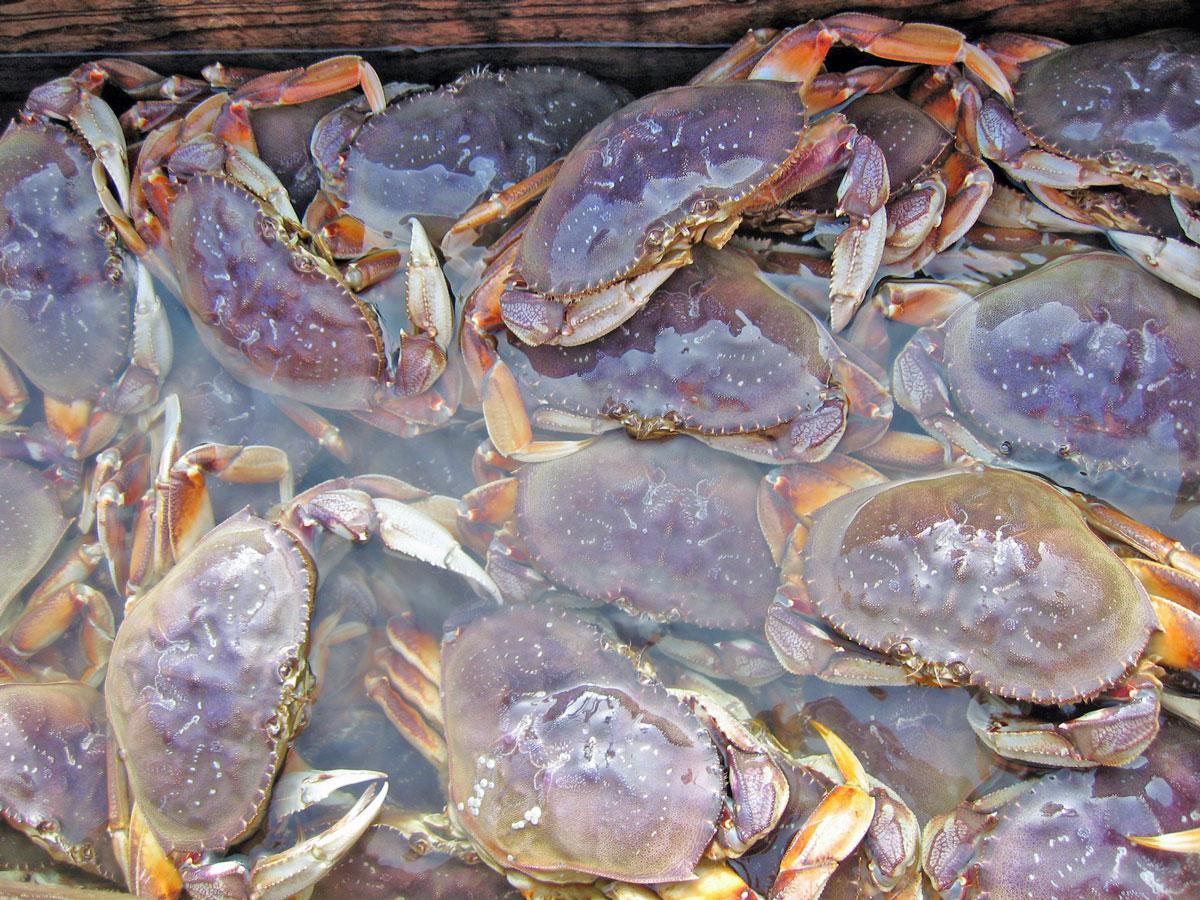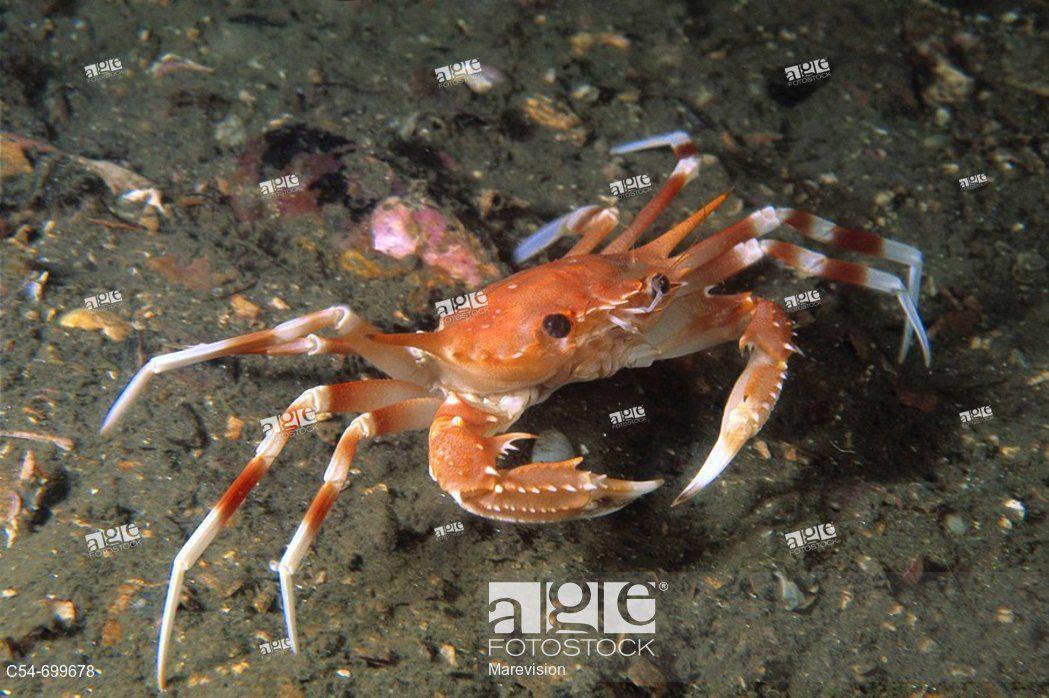The first image is the image on the left, the second image is the image on the right. Evaluate the accuracy of this statement regarding the images: "Atleast one picture of a crab in water.". Is it true? Answer yes or no. Yes. The first image is the image on the left, the second image is the image on the right. Given the left and right images, does the statement "The left image shows a mass of crabs with their purplish-grayish shells facing up, and the right image shows one crab toward the bottom of the seabed facing forward at an angle." hold true? Answer yes or no. Yes. 